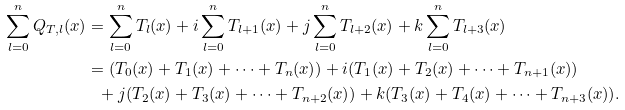Convert formula to latex. <formula><loc_0><loc_0><loc_500><loc_500>\sum _ { l = 0 } ^ { n } Q _ { T , l } ( x ) & = \sum _ { l = 0 } ^ { n } T _ { l } ( x ) + i \sum _ { l = 0 } ^ { n } T _ { l + 1 } ( x ) + j \sum _ { l = 0 } ^ { n } T _ { l + 2 } ( x ) + k \sum _ { l = 0 } ^ { n } T _ { l + 3 } ( x ) \\ & = ( T _ { 0 } ( x ) + T _ { 1 } ( x ) + \cdots + T _ { n } ( x ) ) + i ( T _ { 1 } ( x ) + T _ { 2 } ( x ) + \cdots + T _ { n + 1 } ( x ) ) \\ & \ \ + j ( T _ { 2 } ( x ) + T _ { 3 } ( x ) + \cdots + T _ { n + 2 } ( x ) ) + k ( T _ { 3 } ( x ) + T _ { 4 } ( x ) + \cdots + T _ { n + 3 } ( x ) ) .</formula> 